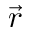<formula> <loc_0><loc_0><loc_500><loc_500>\vec { r }</formula> 